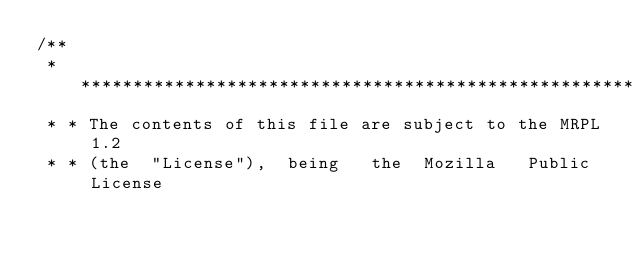<code> <loc_0><loc_0><loc_500><loc_500><_Java_>/**
 * ************************************************************************
 * * The contents of this file are subject to the MRPL 1.2
 * * (the  "License"),  being   the  Mozilla   Public  License</code> 